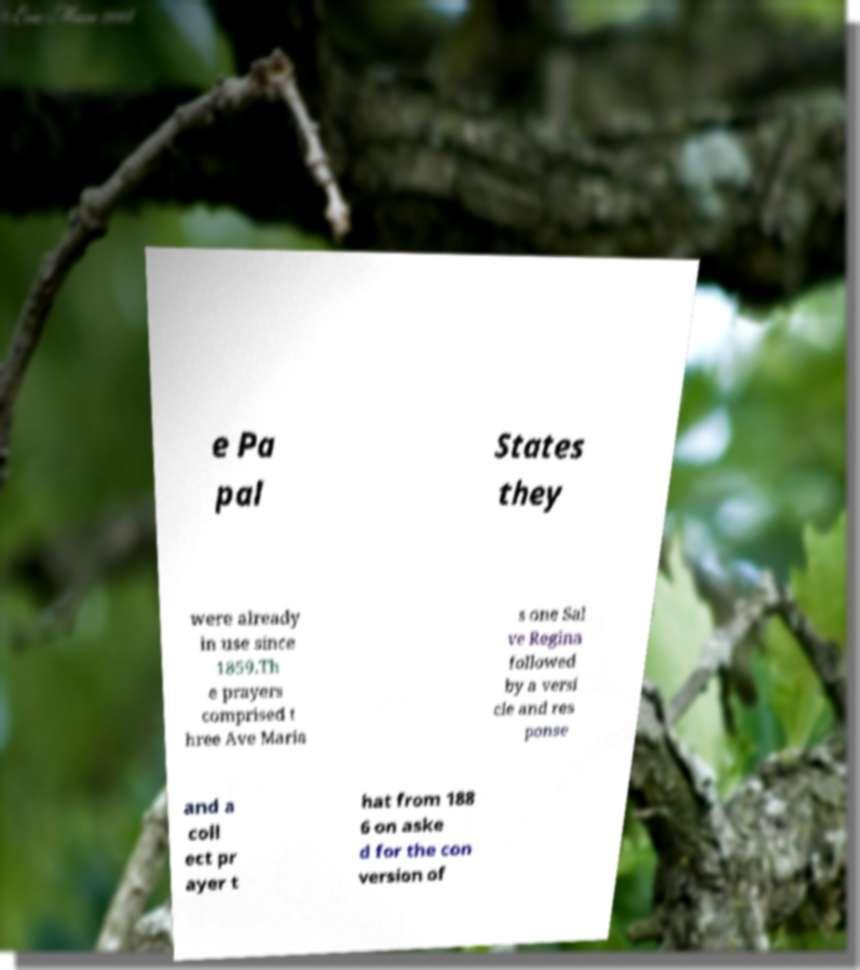What messages or text are displayed in this image? I need them in a readable, typed format. e Pa pal States they were already in use since 1859.Th e prayers comprised t hree Ave Maria s one Sal ve Regina followed by a versi cle and res ponse and a coll ect pr ayer t hat from 188 6 on aske d for the con version of 